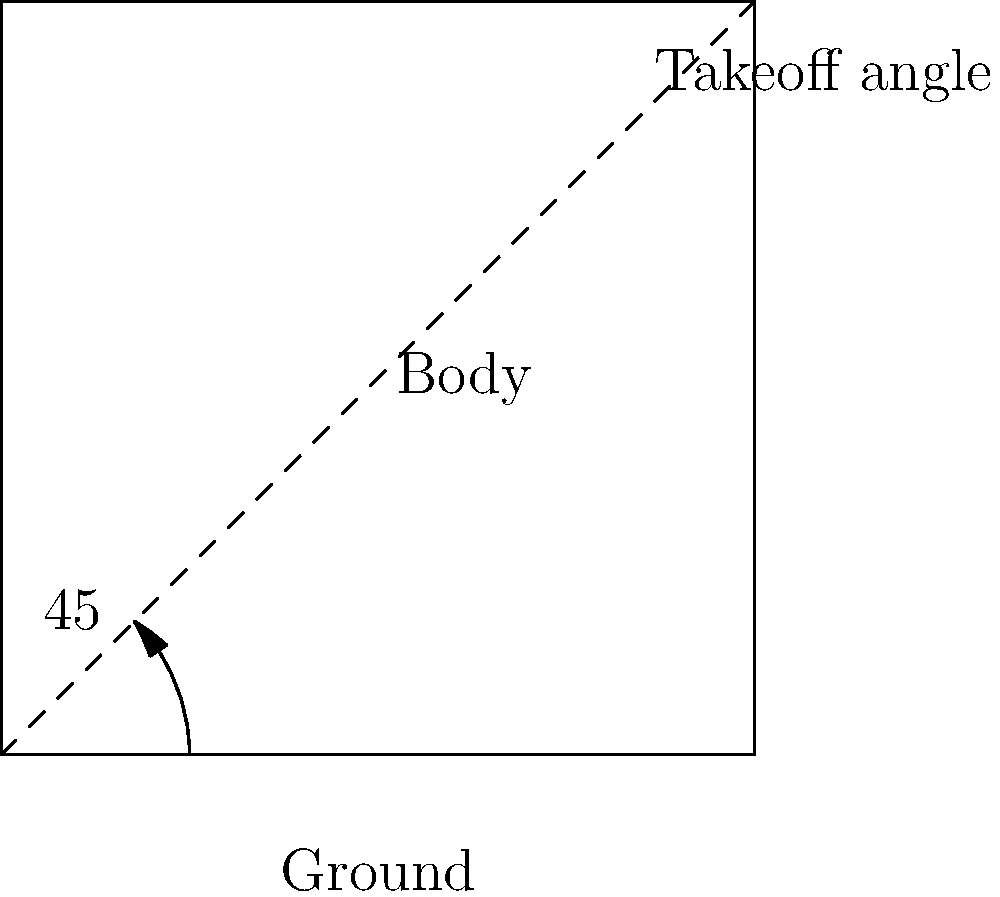As a rookie athlete aiming to improve your long jump performance, what is the optimal takeoff angle to achieve maximum horizontal distance, assuming no air resistance and uniform gravitational field? To determine the optimal takeoff angle for maximum horizontal distance in a jump, we need to consider the principles of projectile motion:

1. In projectile motion, the horizontal and vertical components of velocity are independent.

2. The horizontal velocity remains constant throughout the flight (assuming no air resistance).

3. The vertical velocity changes due to gravity, affecting the time of flight.

4. The horizontal distance traveled is the product of horizontal velocity and time of flight.

5. For a given initial velocity, we want to maximize the product of horizontal velocity and time of flight.

6. The horizontal component of velocity is given by $v_x = v \cos \theta$, where $v$ is the initial velocity and $\theta$ is the takeoff angle.

7. The time of flight is proportional to the vertical component of velocity, $v_y = v \sin \theta$.

8. The horizontal distance is proportional to $v_x \cdot v_y = v^2 \sin \theta \cos \theta$.

9. Using trigonometric identities, we can simplify this to $\frac{1}{2}v^2 \sin 2\theta$.

10. To maximize this function, we need to maximize $\sin 2\theta$.

11. $\sin 2\theta$ reaches its maximum value of 1 when $2\theta = 90°$.

12. Solving for $\theta$, we get $\theta = 45°$.

Therefore, the optimal takeoff angle to achieve maximum horizontal distance in a jump is 45°, as shown in the diagram.
Answer: 45° 